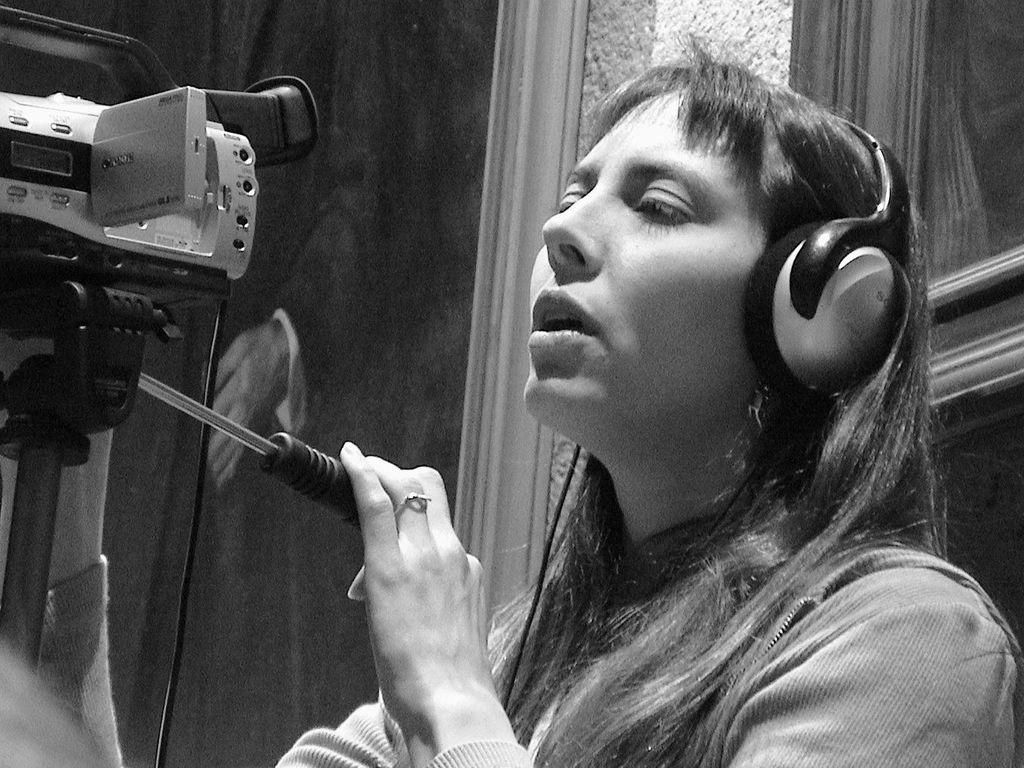Who is present in the image? There is a person in the image. What is the person wearing? The person is wearing headsets. Where is the person standing in relation to the stand? The person is standing in front of a stand. What is attached to the stand? There is a camera attached to the stand. What is the rate of the person's cooking skills in the image? There is no indication of cooking or any cooking skills in the image. 